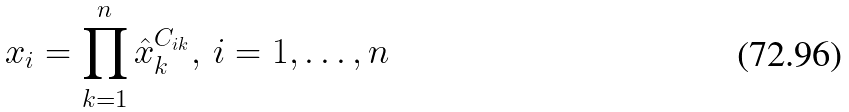<formula> <loc_0><loc_0><loc_500><loc_500>x _ { i } = \prod _ { k = 1 } ^ { n } \hat { x } _ { k } ^ { C _ { i k } } , \, i = 1 , \dots , n</formula> 